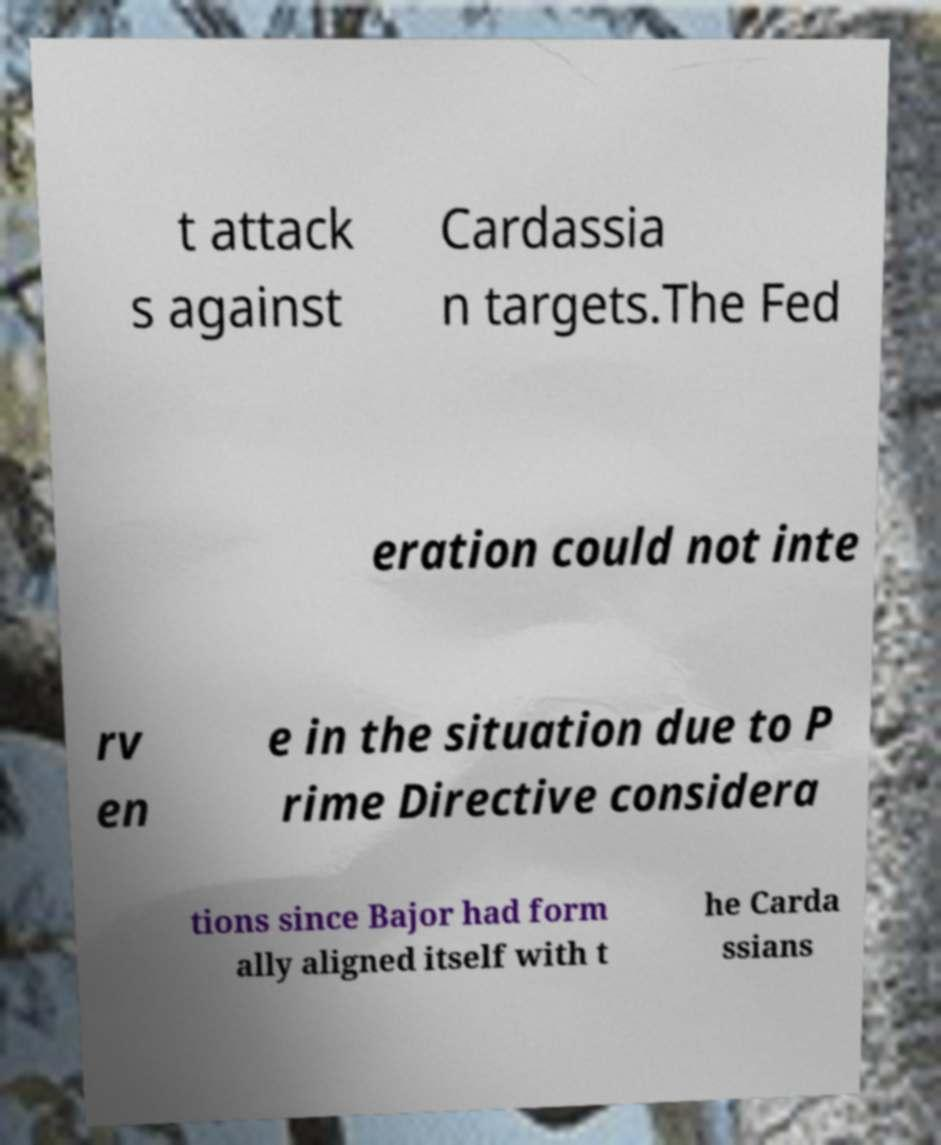I need the written content from this picture converted into text. Can you do that? t attack s against Cardassia n targets.The Fed eration could not inte rv en e in the situation due to P rime Directive considera tions since Bajor had form ally aligned itself with t he Carda ssians 